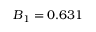<formula> <loc_0><loc_0><loc_500><loc_500>B _ { 1 } = 0 . 6 3 1</formula> 